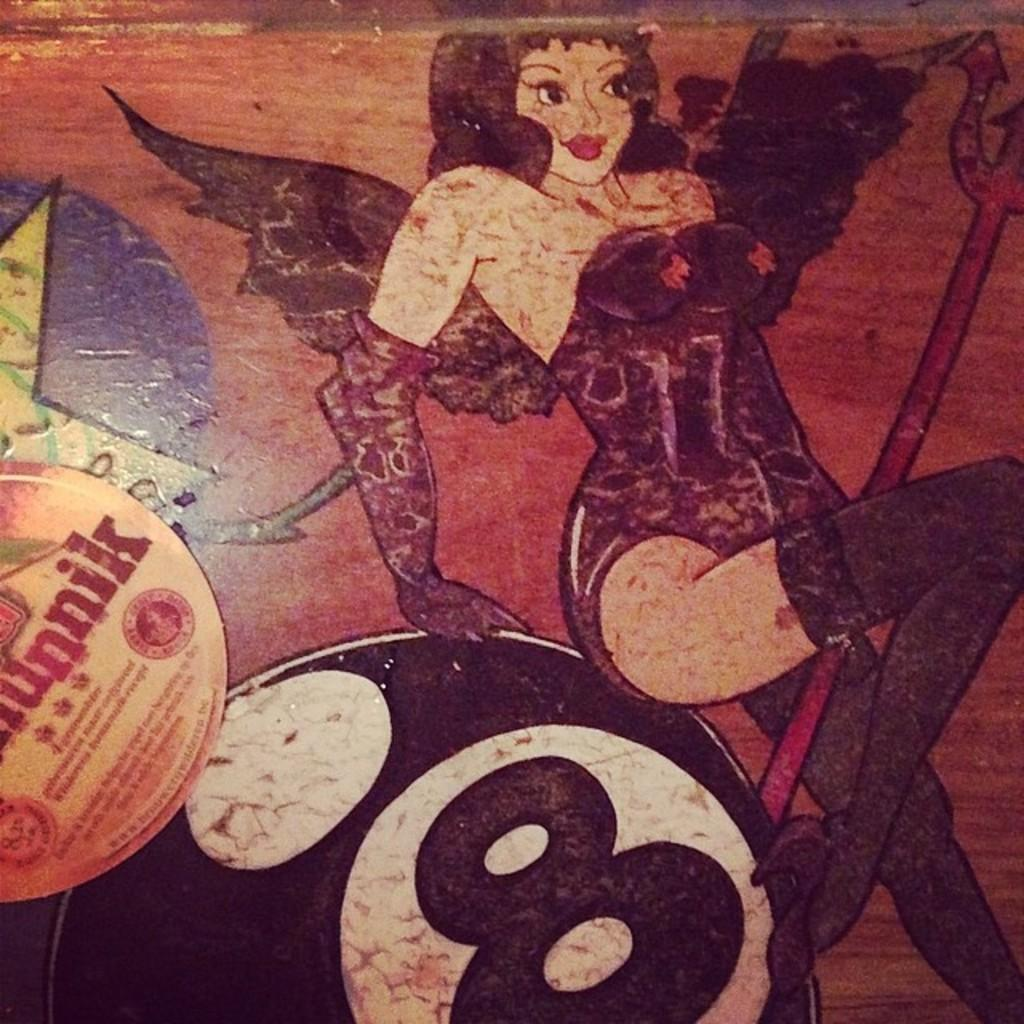What type of table is in the image? There is a wooden table in the image. What is placed on the wooden table? There is a painting on the table. What does the painting depict? The painting depicts a girl. What is the girl wearing in the painting? The girl is wearing a purple dress. What object is at the bottom of the painting? There is a ball at the bottom of the painting. How is the painting created? The entire image is painted on a wooden table. Is the girl's mom present in the painting? There is no mention of the girl's mom in the painting or the image. Can you see any jellyfish in the painting? There are no jellyfish depicted in the painting or the image. 